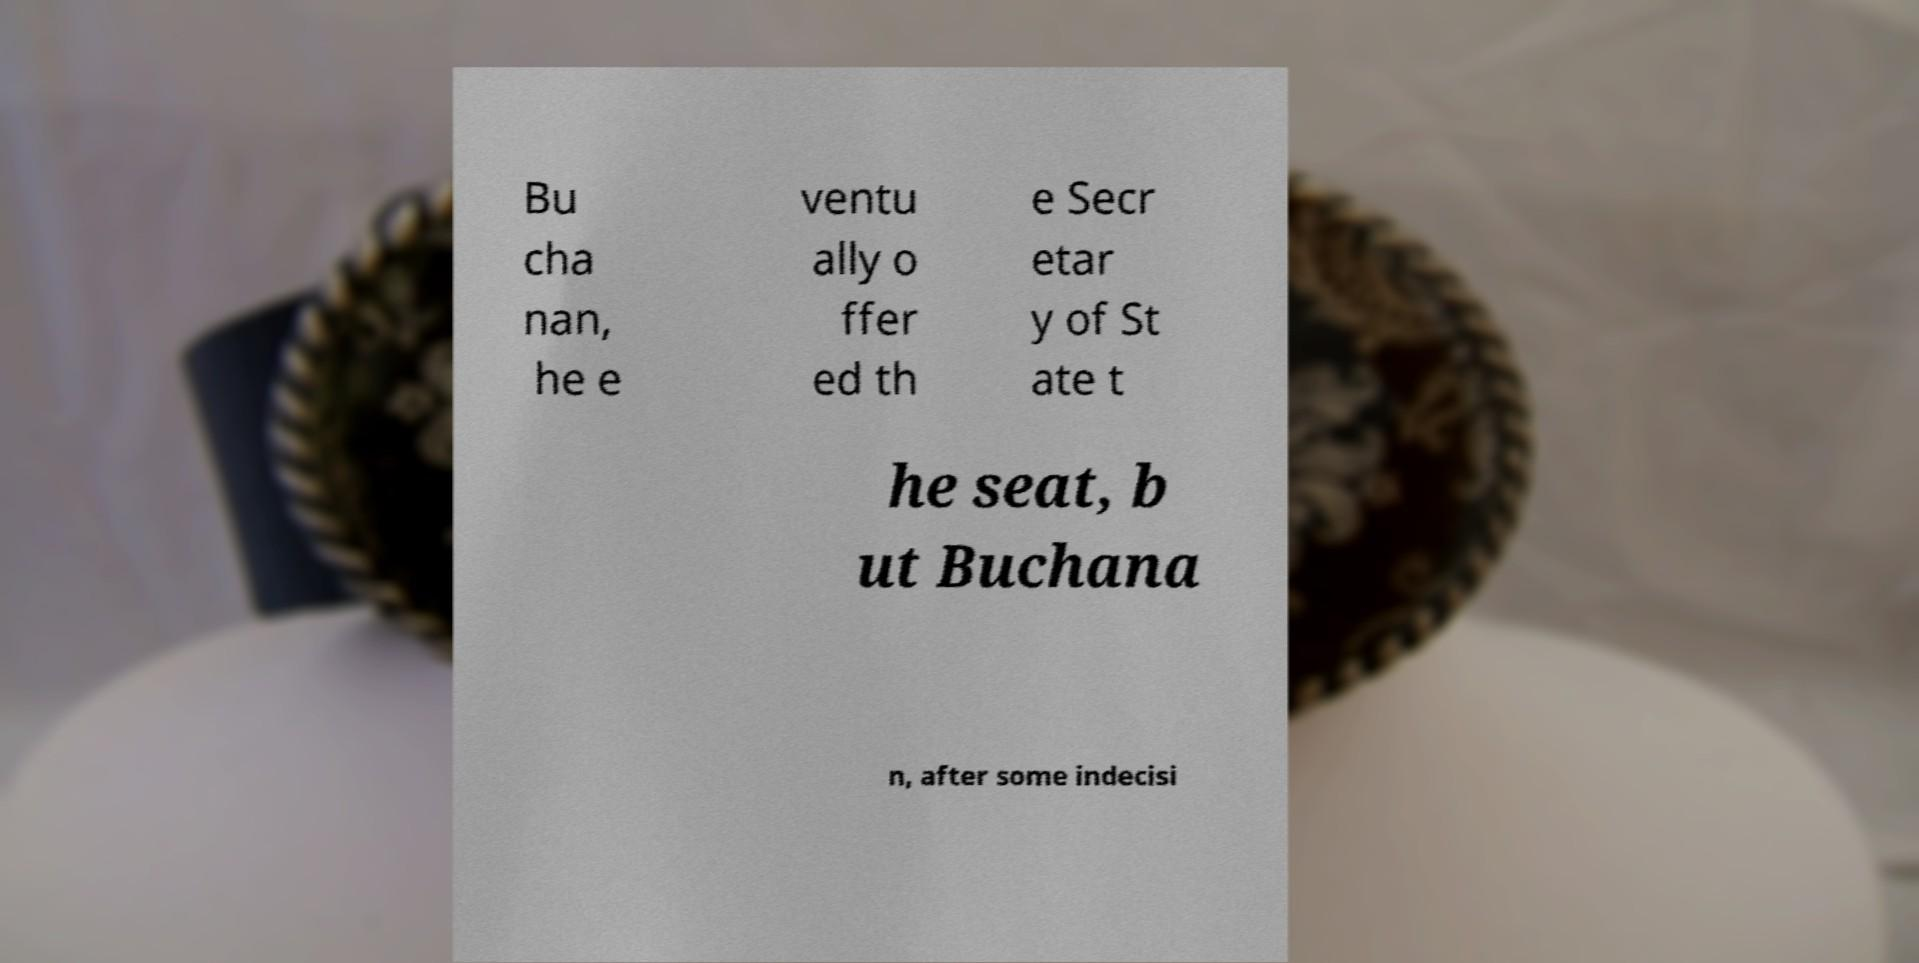Can you accurately transcribe the text from the provided image for me? Bu cha nan, he e ventu ally o ffer ed th e Secr etar y of St ate t he seat, b ut Buchana n, after some indecisi 